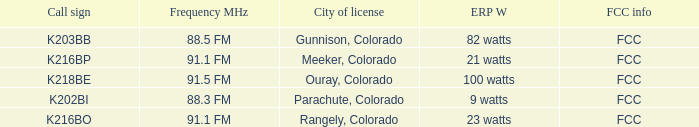Which ERP W has a Frequency MHz of 88.5 FM? 82 watts. 